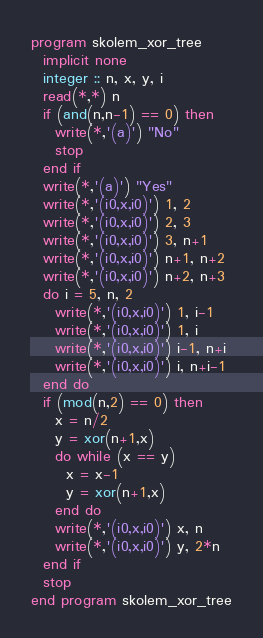<code> <loc_0><loc_0><loc_500><loc_500><_FORTRAN_>program skolem_xor_tree
  implicit none
  integer :: n, x, y, i
  read(*,*) n
  if (and(n,n-1) == 0) then
    write(*,'(a)') "No"
    stop
  end if
  write(*,'(a)') "Yes"
  write(*,'(i0,x,i0)') 1, 2
  write(*,'(i0,x,i0)') 2, 3
  write(*,'(i0,x,i0)') 3, n+1
  write(*,'(i0,x,i0)') n+1, n+2
  write(*,'(i0,x,i0)') n+2, n+3
  do i = 5, n, 2
    write(*,'(i0,x,i0)') 1, i-1
    write(*,'(i0,x,i0)') 1, i
    write(*,'(i0,x,i0)') i-1, n+i
    write(*,'(i0,x,i0)') i, n+i-1
  end do
  if (mod(n,2) == 0) then
    x = n/2
    y = xor(n+1,x)
    do while (x == y)
      x = x-1
      y = xor(n+1,x)
    end do
    write(*,'(i0,x,i0)') x, n
    write(*,'(i0,x,i0)') y, 2*n
  end if
  stop
end program skolem_xor_tree</code> 